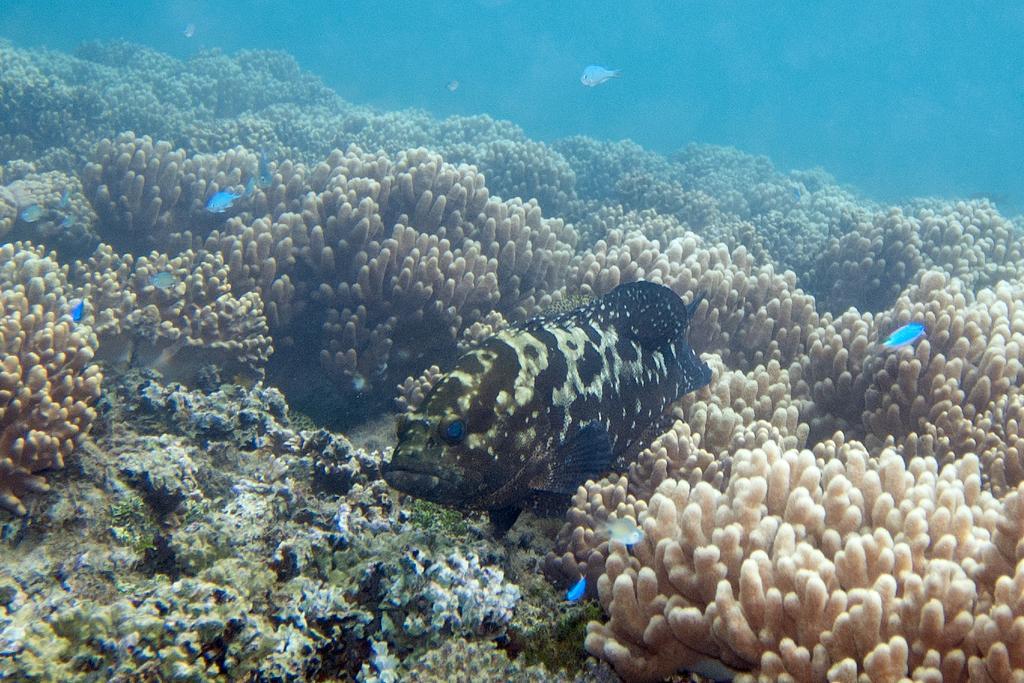Can you describe this image briefly? In the center of the image we can see fish underwater. In the background we can see fish and coral leaves. 